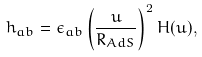<formula> <loc_0><loc_0><loc_500><loc_500>h _ { a b } = \epsilon _ { a b } \left ( \frac { u } { R _ { A d S } } \right ) ^ { 2 } H ( u ) ,</formula> 